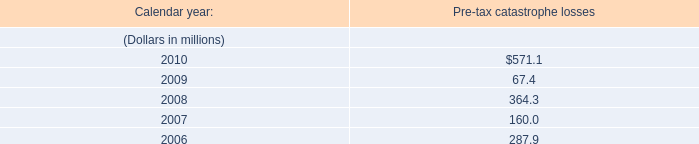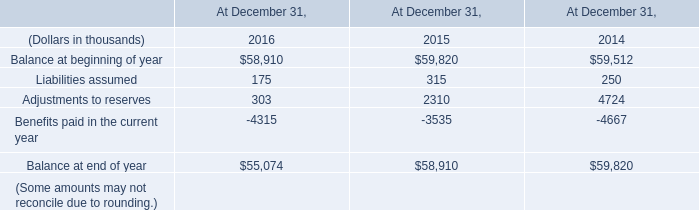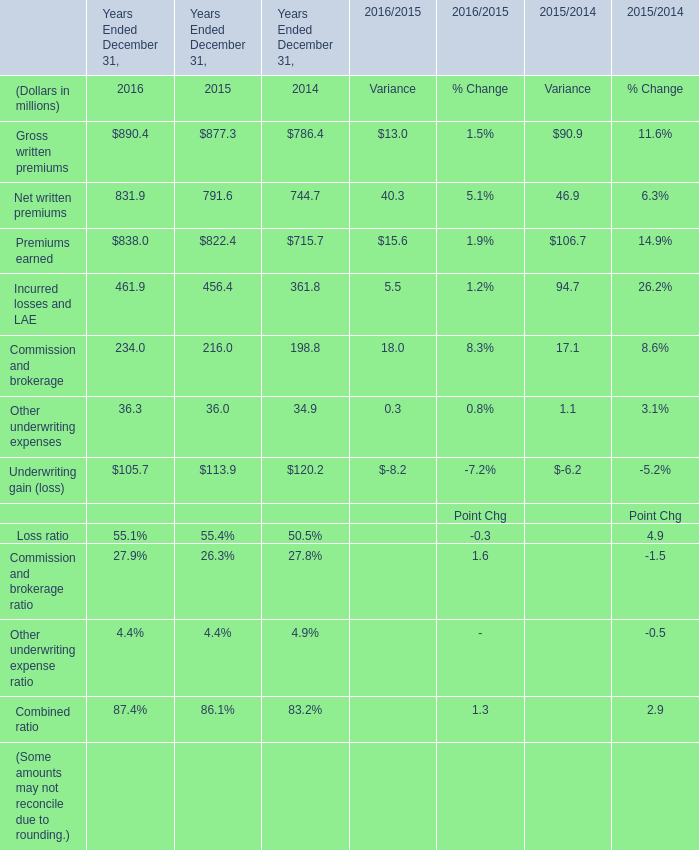Does the value of Underwriting gain (loss) in 2016 greater than that in Years Ended December 31,2015 ? 
Answer: No. 